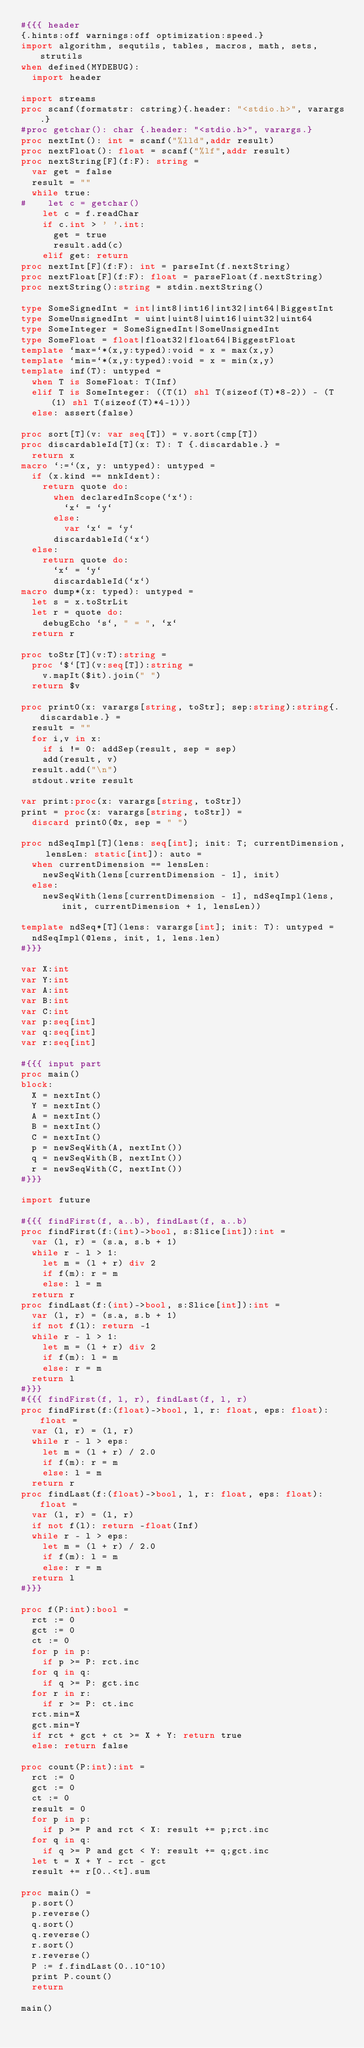Convert code to text. <code><loc_0><loc_0><loc_500><loc_500><_Nim_>#{{{ header
{.hints:off warnings:off optimization:speed.}
import algorithm, sequtils, tables, macros, math, sets, strutils
when defined(MYDEBUG):
  import header

import streams
proc scanf(formatstr: cstring){.header: "<stdio.h>", varargs.}
#proc getchar(): char {.header: "<stdio.h>", varargs.}
proc nextInt(): int = scanf("%lld",addr result)
proc nextFloat(): float = scanf("%lf",addr result)
proc nextString[F](f:F): string =
  var get = false
  result = ""
  while true:
#    let c = getchar()
    let c = f.readChar
    if c.int > ' '.int:
      get = true
      result.add(c)
    elif get: return
proc nextInt[F](f:F): int = parseInt(f.nextString)
proc nextFloat[F](f:F): float = parseFloat(f.nextString)
proc nextString():string = stdin.nextString()

type SomeSignedInt = int|int8|int16|int32|int64|BiggestInt
type SomeUnsignedInt = uint|uint8|uint16|uint32|uint64
type SomeInteger = SomeSignedInt|SomeUnsignedInt
type SomeFloat = float|float32|float64|BiggestFloat
template `max=`*(x,y:typed):void = x = max(x,y)
template `min=`*(x,y:typed):void = x = min(x,y)
template inf(T): untyped = 
  when T is SomeFloat: T(Inf)
  elif T is SomeInteger: ((T(1) shl T(sizeof(T)*8-2)) - (T(1) shl T(sizeof(T)*4-1)))
  else: assert(false)

proc sort[T](v: var seq[T]) = v.sort(cmp[T])
proc discardableId[T](x: T): T {.discardable.} =
  return x
macro `:=`(x, y: untyped): untyped =
  if (x.kind == nnkIdent):
    return quote do:
      when declaredInScope(`x`):
        `x` = `y`
      else:
        var `x` = `y`
      discardableId(`x`)
  else:
    return quote do:
      `x` = `y`
      discardableId(`x`)
macro dump*(x: typed): untyped =
  let s = x.toStrLit
  let r = quote do:
    debugEcho `s`, " = ", `x`
  return r

proc toStr[T](v:T):string =
  proc `$`[T](v:seq[T]):string =
    v.mapIt($it).join(" ")
  return $v

proc print0(x: varargs[string, toStr]; sep:string):string{.discardable.} =
  result = ""
  for i,v in x:
    if i != 0: addSep(result, sep = sep)
    add(result, v)
  result.add("\n")
  stdout.write result

var print:proc(x: varargs[string, toStr])
print = proc(x: varargs[string, toStr]) =
  discard print0(@x, sep = " ")

proc ndSeqImpl[T](lens: seq[int]; init: T; currentDimension, lensLen: static[int]): auto =
  when currentDimension == lensLen:
    newSeqWith(lens[currentDimension - 1], init)
  else:
    newSeqWith(lens[currentDimension - 1], ndSeqImpl(lens, init, currentDimension + 1, lensLen))

template ndSeq*[T](lens: varargs[int]; init: T): untyped =
  ndSeqImpl(@lens, init, 1, lens.len)
#}}}

var X:int
var Y:int
var A:int
var B:int
var C:int
var p:seq[int]
var q:seq[int]
var r:seq[int]

#{{{ input part
proc main()
block:
  X = nextInt()
  Y = nextInt()
  A = nextInt()
  B = nextInt()
  C = nextInt()
  p = newSeqWith(A, nextInt())
  q = newSeqWith(B, nextInt())
  r = newSeqWith(C, nextInt())
#}}}

import future

#{{{ findFirst(f, a..b), findLast(f, a..b)
proc findFirst(f:(int)->bool, s:Slice[int]):int =
  var (l, r) = (s.a, s.b + 1)
  while r - l > 1:
    let m = (l + r) div 2
    if f(m): r = m
    else: l = m
  return r
proc findLast(f:(int)->bool, s:Slice[int]):int =
  var (l, r) = (s.a, s.b + 1)
  if not f(l): return -1
  while r - l > 1:
    let m = (l + r) div 2
    if f(m): l = m
    else: r = m
  return l
#}}}
#{{{ findFirst(f, l, r), findLast(f, l, r)
proc findFirst(f:(float)->bool, l, r: float, eps: float):float =
  var (l, r) = (l, r)
  while r - l > eps:
    let m = (l + r) / 2.0
    if f(m): r = m
    else: l = m
  return r
proc findLast(f:(float)->bool, l, r: float, eps: float):float =
  var (l, r) = (l, r)
  if not f(l): return -float(Inf)
  while r - l > eps:
    let m = (l + r) / 2.0
    if f(m): l = m
    else: r = m
  return l
#}}}

proc f(P:int):bool =
  rct := 0
  gct := 0
  ct := 0
  for p in p:
    if p >= P: rct.inc
  for q in q:
    if q >= P: gct.inc
  for r in r:
    if r >= P: ct.inc
  rct.min=X
  gct.min=Y
  if rct + gct + ct >= X + Y: return true
  else: return false

proc count(P:int):int =
  rct := 0
  gct := 0
  ct := 0
  result = 0
  for p in p:
    if p >= P and rct < X: result += p;rct.inc
  for q in q:
    if q >= P and gct < Y: result += q;gct.inc
  let t = X + Y - rct - gct
  result += r[0..<t].sum

proc main() =
  p.sort()
  p.reverse()
  q.sort()
  q.reverse()
  r.sort()
  r.reverse()
  P := f.findLast(0..10^10)
  print P.count()
  return

main()
</code> 